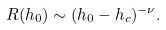<formula> <loc_0><loc_0><loc_500><loc_500>R ( h _ { 0 } ) \sim ( h _ { 0 } - h _ { c } ) ^ { - \nu } .</formula> 